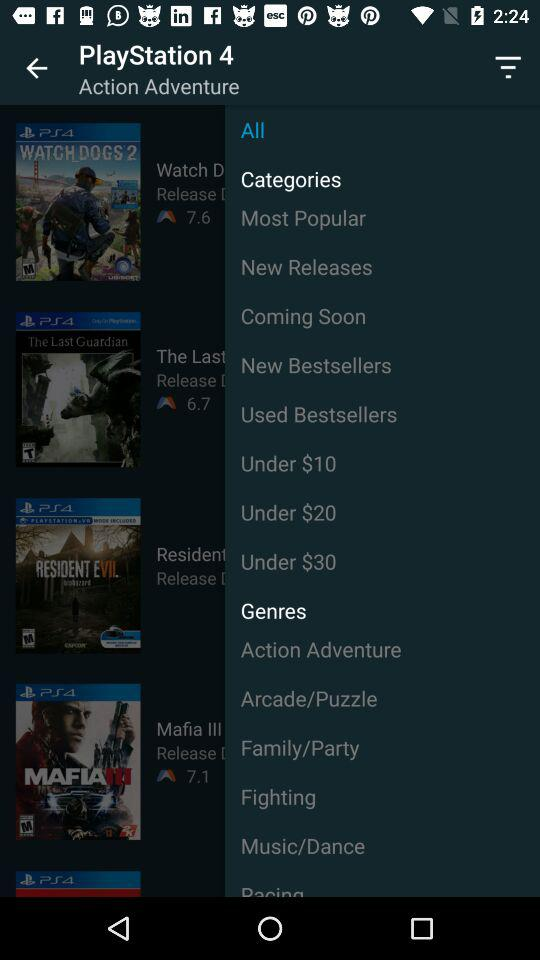How many games with a rating less than 8 are there?
Answer the question using a single word or phrase. 3 